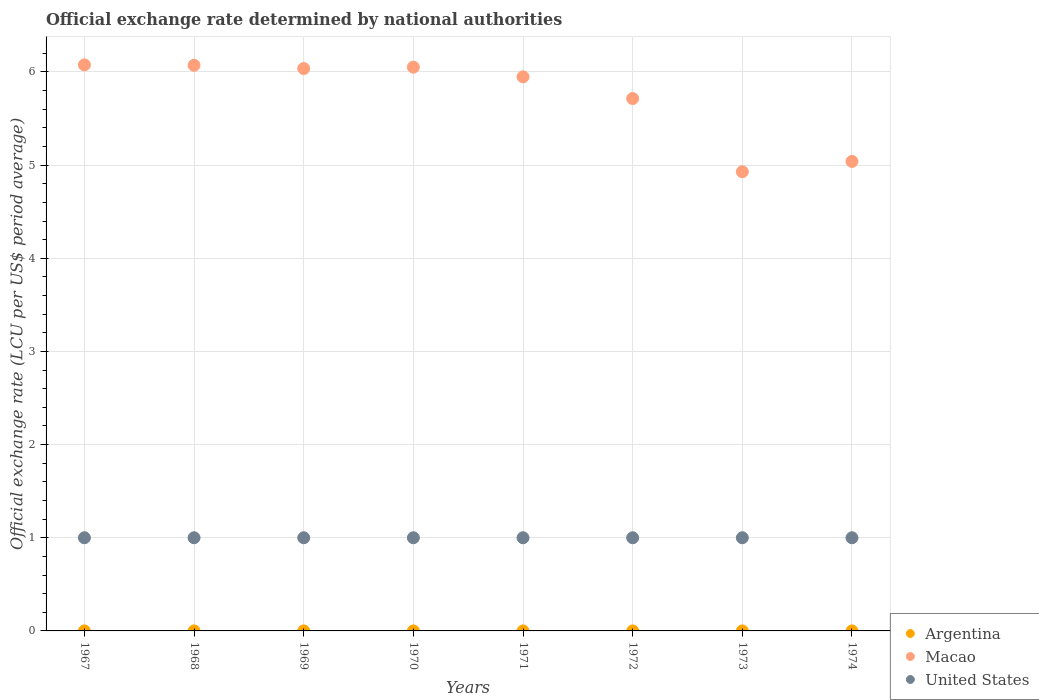How many different coloured dotlines are there?
Provide a short and direct response. 3. What is the official exchange rate in United States in 1970?
Your answer should be compact. 1. Across all years, what is the maximum official exchange rate in Macao?
Offer a terse response. 6.08. Across all years, what is the minimum official exchange rate in Argentina?
Offer a terse response. 3.33424999999917e-11. In which year was the official exchange rate in United States maximum?
Keep it short and to the point. 1967. In which year was the official exchange rate in Argentina minimum?
Provide a short and direct response. 1967. What is the total official exchange rate in United States in the graph?
Keep it short and to the point. 8. What is the difference between the official exchange rate in Argentina in 1967 and that in 1973?
Provide a succinct answer. -1.66574999900083e-11. What is the difference between the official exchange rate in Macao in 1967 and the official exchange rate in Argentina in 1972?
Your response must be concise. 6.08. What is the average official exchange rate in Macao per year?
Provide a short and direct response. 5.73. In the year 1967, what is the difference between the official exchange rate in United States and official exchange rate in Argentina?
Offer a terse response. 1. In how many years, is the official exchange rate in Argentina greater than 3.8 LCU?
Provide a succinct answer. 0. What is the ratio of the official exchange rate in Macao in 1969 to that in 1973?
Make the answer very short. 1.22. Is the difference between the official exchange rate in United States in 1969 and 1972 greater than the difference between the official exchange rate in Argentina in 1969 and 1972?
Provide a succinct answer. Yes. In how many years, is the official exchange rate in United States greater than the average official exchange rate in United States taken over all years?
Your response must be concise. 0. Is the sum of the official exchange rate in Argentina in 1972 and 1973 greater than the maximum official exchange rate in Macao across all years?
Your answer should be compact. No. Is it the case that in every year, the sum of the official exchange rate in Argentina and official exchange rate in United States  is greater than the official exchange rate in Macao?
Provide a succinct answer. No. Is the official exchange rate in Macao strictly less than the official exchange rate in Argentina over the years?
Make the answer very short. No. How many years are there in the graph?
Your answer should be compact. 8. What is the difference between two consecutive major ticks on the Y-axis?
Give a very brief answer. 1. Are the values on the major ticks of Y-axis written in scientific E-notation?
Keep it short and to the point. No. Does the graph contain any zero values?
Offer a terse response. No. Where does the legend appear in the graph?
Your answer should be very brief. Bottom right. How many legend labels are there?
Provide a short and direct response. 3. How are the legend labels stacked?
Provide a succinct answer. Vertical. What is the title of the graph?
Give a very brief answer. Official exchange rate determined by national authorities. What is the label or title of the X-axis?
Provide a short and direct response. Years. What is the label or title of the Y-axis?
Offer a terse response. Official exchange rate (LCU per US$ period average). What is the Official exchange rate (LCU per US$ period average) of Argentina in 1967?
Your answer should be very brief. 3.33424999999917e-11. What is the Official exchange rate (LCU per US$ period average) of Macao in 1967?
Give a very brief answer. 6.08. What is the Official exchange rate (LCU per US$ period average) in Argentina in 1968?
Offer a very short reply. 3.5e-11. What is the Official exchange rate (LCU per US$ period average) of Macao in 1968?
Keep it short and to the point. 6.07. What is the Official exchange rate (LCU per US$ period average) in Argentina in 1969?
Keep it short and to the point. 3.5e-11. What is the Official exchange rate (LCU per US$ period average) of Macao in 1969?
Provide a short and direct response. 6.04. What is the Official exchange rate (LCU per US$ period average) in United States in 1969?
Your response must be concise. 1. What is the Official exchange rate (LCU per US$ period average) in Argentina in 1970?
Your response must be concise. 3.79166666566667e-11. What is the Official exchange rate (LCU per US$ period average) of Macao in 1970?
Make the answer very short. 6.05. What is the Official exchange rate (LCU per US$ period average) in Argentina in 1971?
Offer a terse response. 4.52166666566667e-11. What is the Official exchange rate (LCU per US$ period average) of Macao in 1971?
Provide a short and direct response. 5.95. What is the Official exchange rate (LCU per US$ period average) in Argentina in 1972?
Ensure brevity in your answer.  4.999999999e-11. What is the Official exchange rate (LCU per US$ period average) in Macao in 1972?
Offer a very short reply. 5.71. What is the Official exchange rate (LCU per US$ period average) of United States in 1972?
Your response must be concise. 1. What is the Official exchange rate (LCU per US$ period average) in Argentina in 1973?
Offer a very short reply. 4.999999999e-11. What is the Official exchange rate (LCU per US$ period average) of Macao in 1973?
Provide a short and direct response. 4.93. What is the Official exchange rate (LCU per US$ period average) of Argentina in 1974?
Offer a very short reply. 4.999999999e-11. What is the Official exchange rate (LCU per US$ period average) of Macao in 1974?
Your answer should be very brief. 5.04. What is the Official exchange rate (LCU per US$ period average) of United States in 1974?
Ensure brevity in your answer.  1. Across all years, what is the maximum Official exchange rate (LCU per US$ period average) of Argentina?
Offer a very short reply. 4.999999999e-11. Across all years, what is the maximum Official exchange rate (LCU per US$ period average) of Macao?
Offer a very short reply. 6.08. Across all years, what is the minimum Official exchange rate (LCU per US$ period average) of Argentina?
Your answer should be compact. 3.33424999999917e-11. Across all years, what is the minimum Official exchange rate (LCU per US$ period average) of Macao?
Keep it short and to the point. 4.93. Across all years, what is the minimum Official exchange rate (LCU per US$ period average) of United States?
Make the answer very short. 1. What is the total Official exchange rate (LCU per US$ period average) in Macao in the graph?
Ensure brevity in your answer.  45.87. What is the difference between the Official exchange rate (LCU per US$ period average) in Macao in 1967 and that in 1968?
Give a very brief answer. 0. What is the difference between the Official exchange rate (LCU per US$ period average) of United States in 1967 and that in 1968?
Ensure brevity in your answer.  0. What is the difference between the Official exchange rate (LCU per US$ period average) of Macao in 1967 and that in 1969?
Your answer should be very brief. 0.04. What is the difference between the Official exchange rate (LCU per US$ period average) of United States in 1967 and that in 1969?
Provide a short and direct response. 0. What is the difference between the Official exchange rate (LCU per US$ period average) in Macao in 1967 and that in 1970?
Offer a very short reply. 0.02. What is the difference between the Official exchange rate (LCU per US$ period average) in Argentina in 1967 and that in 1971?
Your answer should be very brief. -0. What is the difference between the Official exchange rate (LCU per US$ period average) in Macao in 1967 and that in 1971?
Provide a succinct answer. 0.13. What is the difference between the Official exchange rate (LCU per US$ period average) of Macao in 1967 and that in 1972?
Your answer should be compact. 0.36. What is the difference between the Official exchange rate (LCU per US$ period average) in Argentina in 1967 and that in 1973?
Your answer should be compact. -0. What is the difference between the Official exchange rate (LCU per US$ period average) of Macao in 1967 and that in 1973?
Ensure brevity in your answer.  1.15. What is the difference between the Official exchange rate (LCU per US$ period average) of United States in 1967 and that in 1973?
Your answer should be compact. 0. What is the difference between the Official exchange rate (LCU per US$ period average) of Argentina in 1967 and that in 1974?
Your answer should be compact. -0. What is the difference between the Official exchange rate (LCU per US$ period average) in Macao in 1967 and that in 1974?
Your answer should be very brief. 1.04. What is the difference between the Official exchange rate (LCU per US$ period average) in United States in 1967 and that in 1974?
Your answer should be very brief. 0. What is the difference between the Official exchange rate (LCU per US$ period average) of Macao in 1968 and that in 1969?
Provide a short and direct response. 0.04. What is the difference between the Official exchange rate (LCU per US$ period average) of United States in 1968 and that in 1969?
Your response must be concise. 0. What is the difference between the Official exchange rate (LCU per US$ period average) in Macao in 1968 and that in 1970?
Your response must be concise. 0.02. What is the difference between the Official exchange rate (LCU per US$ period average) of United States in 1968 and that in 1970?
Give a very brief answer. 0. What is the difference between the Official exchange rate (LCU per US$ period average) in Macao in 1968 and that in 1971?
Give a very brief answer. 0.12. What is the difference between the Official exchange rate (LCU per US$ period average) in United States in 1968 and that in 1971?
Ensure brevity in your answer.  0. What is the difference between the Official exchange rate (LCU per US$ period average) of Argentina in 1968 and that in 1972?
Offer a terse response. -0. What is the difference between the Official exchange rate (LCU per US$ period average) of Macao in 1968 and that in 1972?
Your answer should be very brief. 0.36. What is the difference between the Official exchange rate (LCU per US$ period average) in Macao in 1968 and that in 1973?
Give a very brief answer. 1.14. What is the difference between the Official exchange rate (LCU per US$ period average) of Macao in 1968 and that in 1974?
Your answer should be compact. 1.03. What is the difference between the Official exchange rate (LCU per US$ period average) in Macao in 1969 and that in 1970?
Your answer should be compact. -0.02. What is the difference between the Official exchange rate (LCU per US$ period average) in United States in 1969 and that in 1970?
Offer a very short reply. 0. What is the difference between the Official exchange rate (LCU per US$ period average) in Argentina in 1969 and that in 1971?
Your response must be concise. -0. What is the difference between the Official exchange rate (LCU per US$ period average) of Macao in 1969 and that in 1971?
Provide a succinct answer. 0.09. What is the difference between the Official exchange rate (LCU per US$ period average) in United States in 1969 and that in 1971?
Make the answer very short. 0. What is the difference between the Official exchange rate (LCU per US$ period average) in Macao in 1969 and that in 1972?
Make the answer very short. 0.32. What is the difference between the Official exchange rate (LCU per US$ period average) in Argentina in 1969 and that in 1973?
Your answer should be very brief. -0. What is the difference between the Official exchange rate (LCU per US$ period average) in Macao in 1969 and that in 1973?
Provide a short and direct response. 1.11. What is the difference between the Official exchange rate (LCU per US$ period average) of Argentina in 1969 and that in 1974?
Make the answer very short. -0. What is the difference between the Official exchange rate (LCU per US$ period average) of Macao in 1969 and that in 1974?
Your answer should be very brief. 1. What is the difference between the Official exchange rate (LCU per US$ period average) in United States in 1969 and that in 1974?
Offer a terse response. 0. What is the difference between the Official exchange rate (LCU per US$ period average) in Argentina in 1970 and that in 1971?
Provide a succinct answer. -0. What is the difference between the Official exchange rate (LCU per US$ period average) in Macao in 1970 and that in 1971?
Offer a terse response. 0.1. What is the difference between the Official exchange rate (LCU per US$ period average) of Argentina in 1970 and that in 1972?
Your response must be concise. -0. What is the difference between the Official exchange rate (LCU per US$ period average) in Macao in 1970 and that in 1972?
Make the answer very short. 0.34. What is the difference between the Official exchange rate (LCU per US$ period average) of Argentina in 1970 and that in 1973?
Offer a terse response. -0. What is the difference between the Official exchange rate (LCU per US$ period average) in Macao in 1970 and that in 1973?
Offer a terse response. 1.12. What is the difference between the Official exchange rate (LCU per US$ period average) of Argentina in 1970 and that in 1974?
Ensure brevity in your answer.  -0. What is the difference between the Official exchange rate (LCU per US$ period average) in Macao in 1970 and that in 1974?
Keep it short and to the point. 1.01. What is the difference between the Official exchange rate (LCU per US$ period average) of United States in 1970 and that in 1974?
Your answer should be compact. 0. What is the difference between the Official exchange rate (LCU per US$ period average) in Macao in 1971 and that in 1972?
Offer a very short reply. 0.23. What is the difference between the Official exchange rate (LCU per US$ period average) in Argentina in 1971 and that in 1973?
Offer a terse response. -0. What is the difference between the Official exchange rate (LCU per US$ period average) of Macao in 1971 and that in 1973?
Make the answer very short. 1.02. What is the difference between the Official exchange rate (LCU per US$ period average) of Argentina in 1971 and that in 1974?
Offer a terse response. -0. What is the difference between the Official exchange rate (LCU per US$ period average) in Macao in 1971 and that in 1974?
Provide a succinct answer. 0.91. What is the difference between the Official exchange rate (LCU per US$ period average) in United States in 1971 and that in 1974?
Ensure brevity in your answer.  0. What is the difference between the Official exchange rate (LCU per US$ period average) in Macao in 1972 and that in 1973?
Provide a succinct answer. 0.79. What is the difference between the Official exchange rate (LCU per US$ period average) of Argentina in 1972 and that in 1974?
Ensure brevity in your answer.  0. What is the difference between the Official exchange rate (LCU per US$ period average) in Macao in 1972 and that in 1974?
Make the answer very short. 0.67. What is the difference between the Official exchange rate (LCU per US$ period average) of United States in 1972 and that in 1974?
Your answer should be compact. 0. What is the difference between the Official exchange rate (LCU per US$ period average) of Argentina in 1973 and that in 1974?
Offer a terse response. 0. What is the difference between the Official exchange rate (LCU per US$ period average) of Macao in 1973 and that in 1974?
Your response must be concise. -0.11. What is the difference between the Official exchange rate (LCU per US$ period average) of Argentina in 1967 and the Official exchange rate (LCU per US$ period average) of Macao in 1968?
Your answer should be very brief. -6.07. What is the difference between the Official exchange rate (LCU per US$ period average) of Macao in 1967 and the Official exchange rate (LCU per US$ period average) of United States in 1968?
Your response must be concise. 5.08. What is the difference between the Official exchange rate (LCU per US$ period average) of Argentina in 1967 and the Official exchange rate (LCU per US$ period average) of Macao in 1969?
Your response must be concise. -6.04. What is the difference between the Official exchange rate (LCU per US$ period average) of Macao in 1967 and the Official exchange rate (LCU per US$ period average) of United States in 1969?
Ensure brevity in your answer.  5.08. What is the difference between the Official exchange rate (LCU per US$ period average) of Argentina in 1967 and the Official exchange rate (LCU per US$ period average) of Macao in 1970?
Ensure brevity in your answer.  -6.05. What is the difference between the Official exchange rate (LCU per US$ period average) of Argentina in 1967 and the Official exchange rate (LCU per US$ period average) of United States in 1970?
Offer a very short reply. -1. What is the difference between the Official exchange rate (LCU per US$ period average) in Macao in 1967 and the Official exchange rate (LCU per US$ period average) in United States in 1970?
Your answer should be compact. 5.08. What is the difference between the Official exchange rate (LCU per US$ period average) in Argentina in 1967 and the Official exchange rate (LCU per US$ period average) in Macao in 1971?
Offer a terse response. -5.95. What is the difference between the Official exchange rate (LCU per US$ period average) of Argentina in 1967 and the Official exchange rate (LCU per US$ period average) of United States in 1971?
Provide a short and direct response. -1. What is the difference between the Official exchange rate (LCU per US$ period average) in Macao in 1967 and the Official exchange rate (LCU per US$ period average) in United States in 1971?
Your answer should be very brief. 5.08. What is the difference between the Official exchange rate (LCU per US$ period average) in Argentina in 1967 and the Official exchange rate (LCU per US$ period average) in Macao in 1972?
Make the answer very short. -5.71. What is the difference between the Official exchange rate (LCU per US$ period average) of Macao in 1967 and the Official exchange rate (LCU per US$ period average) of United States in 1972?
Keep it short and to the point. 5.08. What is the difference between the Official exchange rate (LCU per US$ period average) of Argentina in 1967 and the Official exchange rate (LCU per US$ period average) of Macao in 1973?
Offer a very short reply. -4.93. What is the difference between the Official exchange rate (LCU per US$ period average) in Argentina in 1967 and the Official exchange rate (LCU per US$ period average) in United States in 1973?
Your answer should be compact. -1. What is the difference between the Official exchange rate (LCU per US$ period average) in Macao in 1967 and the Official exchange rate (LCU per US$ period average) in United States in 1973?
Offer a very short reply. 5.08. What is the difference between the Official exchange rate (LCU per US$ period average) of Argentina in 1967 and the Official exchange rate (LCU per US$ period average) of Macao in 1974?
Give a very brief answer. -5.04. What is the difference between the Official exchange rate (LCU per US$ period average) of Macao in 1967 and the Official exchange rate (LCU per US$ period average) of United States in 1974?
Make the answer very short. 5.08. What is the difference between the Official exchange rate (LCU per US$ period average) in Argentina in 1968 and the Official exchange rate (LCU per US$ period average) in Macao in 1969?
Your response must be concise. -6.04. What is the difference between the Official exchange rate (LCU per US$ period average) of Argentina in 1968 and the Official exchange rate (LCU per US$ period average) of United States in 1969?
Give a very brief answer. -1. What is the difference between the Official exchange rate (LCU per US$ period average) of Macao in 1968 and the Official exchange rate (LCU per US$ period average) of United States in 1969?
Provide a short and direct response. 5.07. What is the difference between the Official exchange rate (LCU per US$ period average) in Argentina in 1968 and the Official exchange rate (LCU per US$ period average) in Macao in 1970?
Your answer should be compact. -6.05. What is the difference between the Official exchange rate (LCU per US$ period average) of Argentina in 1968 and the Official exchange rate (LCU per US$ period average) of United States in 1970?
Make the answer very short. -1. What is the difference between the Official exchange rate (LCU per US$ period average) of Macao in 1968 and the Official exchange rate (LCU per US$ period average) of United States in 1970?
Keep it short and to the point. 5.07. What is the difference between the Official exchange rate (LCU per US$ period average) of Argentina in 1968 and the Official exchange rate (LCU per US$ period average) of Macao in 1971?
Make the answer very short. -5.95. What is the difference between the Official exchange rate (LCU per US$ period average) in Argentina in 1968 and the Official exchange rate (LCU per US$ period average) in United States in 1971?
Make the answer very short. -1. What is the difference between the Official exchange rate (LCU per US$ period average) in Macao in 1968 and the Official exchange rate (LCU per US$ period average) in United States in 1971?
Your answer should be very brief. 5.07. What is the difference between the Official exchange rate (LCU per US$ period average) of Argentina in 1968 and the Official exchange rate (LCU per US$ period average) of Macao in 1972?
Your response must be concise. -5.71. What is the difference between the Official exchange rate (LCU per US$ period average) of Macao in 1968 and the Official exchange rate (LCU per US$ period average) of United States in 1972?
Give a very brief answer. 5.07. What is the difference between the Official exchange rate (LCU per US$ period average) of Argentina in 1968 and the Official exchange rate (LCU per US$ period average) of Macao in 1973?
Give a very brief answer. -4.93. What is the difference between the Official exchange rate (LCU per US$ period average) of Argentina in 1968 and the Official exchange rate (LCU per US$ period average) of United States in 1973?
Keep it short and to the point. -1. What is the difference between the Official exchange rate (LCU per US$ period average) in Macao in 1968 and the Official exchange rate (LCU per US$ period average) in United States in 1973?
Offer a terse response. 5.07. What is the difference between the Official exchange rate (LCU per US$ period average) in Argentina in 1968 and the Official exchange rate (LCU per US$ period average) in Macao in 1974?
Ensure brevity in your answer.  -5.04. What is the difference between the Official exchange rate (LCU per US$ period average) in Macao in 1968 and the Official exchange rate (LCU per US$ period average) in United States in 1974?
Your answer should be very brief. 5.07. What is the difference between the Official exchange rate (LCU per US$ period average) in Argentina in 1969 and the Official exchange rate (LCU per US$ period average) in Macao in 1970?
Your answer should be very brief. -6.05. What is the difference between the Official exchange rate (LCU per US$ period average) in Macao in 1969 and the Official exchange rate (LCU per US$ period average) in United States in 1970?
Your response must be concise. 5.04. What is the difference between the Official exchange rate (LCU per US$ period average) in Argentina in 1969 and the Official exchange rate (LCU per US$ period average) in Macao in 1971?
Offer a terse response. -5.95. What is the difference between the Official exchange rate (LCU per US$ period average) of Argentina in 1969 and the Official exchange rate (LCU per US$ period average) of United States in 1971?
Your response must be concise. -1. What is the difference between the Official exchange rate (LCU per US$ period average) in Macao in 1969 and the Official exchange rate (LCU per US$ period average) in United States in 1971?
Your answer should be compact. 5.04. What is the difference between the Official exchange rate (LCU per US$ period average) in Argentina in 1969 and the Official exchange rate (LCU per US$ period average) in Macao in 1972?
Your answer should be compact. -5.71. What is the difference between the Official exchange rate (LCU per US$ period average) of Argentina in 1969 and the Official exchange rate (LCU per US$ period average) of United States in 1972?
Provide a short and direct response. -1. What is the difference between the Official exchange rate (LCU per US$ period average) of Macao in 1969 and the Official exchange rate (LCU per US$ period average) of United States in 1972?
Ensure brevity in your answer.  5.04. What is the difference between the Official exchange rate (LCU per US$ period average) of Argentina in 1969 and the Official exchange rate (LCU per US$ period average) of Macao in 1973?
Offer a very short reply. -4.93. What is the difference between the Official exchange rate (LCU per US$ period average) of Argentina in 1969 and the Official exchange rate (LCU per US$ period average) of United States in 1973?
Make the answer very short. -1. What is the difference between the Official exchange rate (LCU per US$ period average) in Macao in 1969 and the Official exchange rate (LCU per US$ period average) in United States in 1973?
Offer a terse response. 5.04. What is the difference between the Official exchange rate (LCU per US$ period average) of Argentina in 1969 and the Official exchange rate (LCU per US$ period average) of Macao in 1974?
Make the answer very short. -5.04. What is the difference between the Official exchange rate (LCU per US$ period average) in Argentina in 1969 and the Official exchange rate (LCU per US$ period average) in United States in 1974?
Provide a short and direct response. -1. What is the difference between the Official exchange rate (LCU per US$ period average) of Macao in 1969 and the Official exchange rate (LCU per US$ period average) of United States in 1974?
Your answer should be compact. 5.04. What is the difference between the Official exchange rate (LCU per US$ period average) of Argentina in 1970 and the Official exchange rate (LCU per US$ period average) of Macao in 1971?
Your response must be concise. -5.95. What is the difference between the Official exchange rate (LCU per US$ period average) in Macao in 1970 and the Official exchange rate (LCU per US$ period average) in United States in 1971?
Make the answer very short. 5.05. What is the difference between the Official exchange rate (LCU per US$ period average) in Argentina in 1970 and the Official exchange rate (LCU per US$ period average) in Macao in 1972?
Your response must be concise. -5.71. What is the difference between the Official exchange rate (LCU per US$ period average) of Macao in 1970 and the Official exchange rate (LCU per US$ period average) of United States in 1972?
Your answer should be very brief. 5.05. What is the difference between the Official exchange rate (LCU per US$ period average) of Argentina in 1970 and the Official exchange rate (LCU per US$ period average) of Macao in 1973?
Your answer should be very brief. -4.93. What is the difference between the Official exchange rate (LCU per US$ period average) of Argentina in 1970 and the Official exchange rate (LCU per US$ period average) of United States in 1973?
Offer a terse response. -1. What is the difference between the Official exchange rate (LCU per US$ period average) in Macao in 1970 and the Official exchange rate (LCU per US$ period average) in United States in 1973?
Make the answer very short. 5.05. What is the difference between the Official exchange rate (LCU per US$ period average) of Argentina in 1970 and the Official exchange rate (LCU per US$ period average) of Macao in 1974?
Provide a short and direct response. -5.04. What is the difference between the Official exchange rate (LCU per US$ period average) in Macao in 1970 and the Official exchange rate (LCU per US$ period average) in United States in 1974?
Your answer should be compact. 5.05. What is the difference between the Official exchange rate (LCU per US$ period average) in Argentina in 1971 and the Official exchange rate (LCU per US$ period average) in Macao in 1972?
Give a very brief answer. -5.71. What is the difference between the Official exchange rate (LCU per US$ period average) of Argentina in 1971 and the Official exchange rate (LCU per US$ period average) of United States in 1972?
Give a very brief answer. -1. What is the difference between the Official exchange rate (LCU per US$ period average) in Macao in 1971 and the Official exchange rate (LCU per US$ period average) in United States in 1972?
Give a very brief answer. 4.95. What is the difference between the Official exchange rate (LCU per US$ period average) in Argentina in 1971 and the Official exchange rate (LCU per US$ period average) in Macao in 1973?
Keep it short and to the point. -4.93. What is the difference between the Official exchange rate (LCU per US$ period average) of Argentina in 1971 and the Official exchange rate (LCU per US$ period average) of United States in 1973?
Offer a terse response. -1. What is the difference between the Official exchange rate (LCU per US$ period average) in Macao in 1971 and the Official exchange rate (LCU per US$ period average) in United States in 1973?
Offer a very short reply. 4.95. What is the difference between the Official exchange rate (LCU per US$ period average) in Argentina in 1971 and the Official exchange rate (LCU per US$ period average) in Macao in 1974?
Make the answer very short. -5.04. What is the difference between the Official exchange rate (LCU per US$ period average) in Argentina in 1971 and the Official exchange rate (LCU per US$ period average) in United States in 1974?
Offer a very short reply. -1. What is the difference between the Official exchange rate (LCU per US$ period average) in Macao in 1971 and the Official exchange rate (LCU per US$ period average) in United States in 1974?
Your response must be concise. 4.95. What is the difference between the Official exchange rate (LCU per US$ period average) of Argentina in 1972 and the Official exchange rate (LCU per US$ period average) of Macao in 1973?
Your answer should be compact. -4.93. What is the difference between the Official exchange rate (LCU per US$ period average) in Macao in 1972 and the Official exchange rate (LCU per US$ period average) in United States in 1973?
Ensure brevity in your answer.  4.71. What is the difference between the Official exchange rate (LCU per US$ period average) in Argentina in 1972 and the Official exchange rate (LCU per US$ period average) in Macao in 1974?
Keep it short and to the point. -5.04. What is the difference between the Official exchange rate (LCU per US$ period average) in Argentina in 1972 and the Official exchange rate (LCU per US$ period average) in United States in 1974?
Make the answer very short. -1. What is the difference between the Official exchange rate (LCU per US$ period average) of Macao in 1972 and the Official exchange rate (LCU per US$ period average) of United States in 1974?
Your response must be concise. 4.71. What is the difference between the Official exchange rate (LCU per US$ period average) of Argentina in 1973 and the Official exchange rate (LCU per US$ period average) of Macao in 1974?
Make the answer very short. -5.04. What is the difference between the Official exchange rate (LCU per US$ period average) of Argentina in 1973 and the Official exchange rate (LCU per US$ period average) of United States in 1974?
Offer a terse response. -1. What is the difference between the Official exchange rate (LCU per US$ period average) of Macao in 1973 and the Official exchange rate (LCU per US$ period average) of United States in 1974?
Your answer should be compact. 3.93. What is the average Official exchange rate (LCU per US$ period average) in Macao per year?
Provide a short and direct response. 5.73. What is the average Official exchange rate (LCU per US$ period average) of United States per year?
Offer a terse response. 1. In the year 1967, what is the difference between the Official exchange rate (LCU per US$ period average) of Argentina and Official exchange rate (LCU per US$ period average) of Macao?
Ensure brevity in your answer.  -6.08. In the year 1967, what is the difference between the Official exchange rate (LCU per US$ period average) in Macao and Official exchange rate (LCU per US$ period average) in United States?
Ensure brevity in your answer.  5.08. In the year 1968, what is the difference between the Official exchange rate (LCU per US$ period average) in Argentina and Official exchange rate (LCU per US$ period average) in Macao?
Provide a succinct answer. -6.07. In the year 1968, what is the difference between the Official exchange rate (LCU per US$ period average) of Macao and Official exchange rate (LCU per US$ period average) of United States?
Provide a short and direct response. 5.07. In the year 1969, what is the difference between the Official exchange rate (LCU per US$ period average) of Argentina and Official exchange rate (LCU per US$ period average) of Macao?
Offer a very short reply. -6.04. In the year 1969, what is the difference between the Official exchange rate (LCU per US$ period average) of Argentina and Official exchange rate (LCU per US$ period average) of United States?
Your answer should be compact. -1. In the year 1969, what is the difference between the Official exchange rate (LCU per US$ period average) in Macao and Official exchange rate (LCU per US$ period average) in United States?
Make the answer very short. 5.04. In the year 1970, what is the difference between the Official exchange rate (LCU per US$ period average) of Argentina and Official exchange rate (LCU per US$ period average) of Macao?
Give a very brief answer. -6.05. In the year 1970, what is the difference between the Official exchange rate (LCU per US$ period average) of Macao and Official exchange rate (LCU per US$ period average) of United States?
Ensure brevity in your answer.  5.05. In the year 1971, what is the difference between the Official exchange rate (LCU per US$ period average) in Argentina and Official exchange rate (LCU per US$ period average) in Macao?
Your answer should be very brief. -5.95. In the year 1971, what is the difference between the Official exchange rate (LCU per US$ period average) in Argentina and Official exchange rate (LCU per US$ period average) in United States?
Offer a very short reply. -1. In the year 1971, what is the difference between the Official exchange rate (LCU per US$ period average) in Macao and Official exchange rate (LCU per US$ period average) in United States?
Ensure brevity in your answer.  4.95. In the year 1972, what is the difference between the Official exchange rate (LCU per US$ period average) in Argentina and Official exchange rate (LCU per US$ period average) in Macao?
Make the answer very short. -5.71. In the year 1972, what is the difference between the Official exchange rate (LCU per US$ period average) in Argentina and Official exchange rate (LCU per US$ period average) in United States?
Make the answer very short. -1. In the year 1972, what is the difference between the Official exchange rate (LCU per US$ period average) of Macao and Official exchange rate (LCU per US$ period average) of United States?
Offer a very short reply. 4.71. In the year 1973, what is the difference between the Official exchange rate (LCU per US$ period average) of Argentina and Official exchange rate (LCU per US$ period average) of Macao?
Your response must be concise. -4.93. In the year 1973, what is the difference between the Official exchange rate (LCU per US$ period average) in Macao and Official exchange rate (LCU per US$ period average) in United States?
Give a very brief answer. 3.93. In the year 1974, what is the difference between the Official exchange rate (LCU per US$ period average) in Argentina and Official exchange rate (LCU per US$ period average) in Macao?
Offer a very short reply. -5.04. In the year 1974, what is the difference between the Official exchange rate (LCU per US$ period average) in Macao and Official exchange rate (LCU per US$ period average) in United States?
Give a very brief answer. 4.04. What is the ratio of the Official exchange rate (LCU per US$ period average) of Argentina in 1967 to that in 1968?
Your answer should be very brief. 0.95. What is the ratio of the Official exchange rate (LCU per US$ period average) in Argentina in 1967 to that in 1969?
Your answer should be compact. 0.95. What is the ratio of the Official exchange rate (LCU per US$ period average) of Macao in 1967 to that in 1969?
Offer a very short reply. 1.01. What is the ratio of the Official exchange rate (LCU per US$ period average) in Argentina in 1967 to that in 1970?
Ensure brevity in your answer.  0.88. What is the ratio of the Official exchange rate (LCU per US$ period average) of United States in 1967 to that in 1970?
Your answer should be compact. 1. What is the ratio of the Official exchange rate (LCU per US$ period average) in Argentina in 1967 to that in 1971?
Provide a succinct answer. 0.74. What is the ratio of the Official exchange rate (LCU per US$ period average) of Macao in 1967 to that in 1971?
Your answer should be compact. 1.02. What is the ratio of the Official exchange rate (LCU per US$ period average) in United States in 1967 to that in 1971?
Offer a very short reply. 1. What is the ratio of the Official exchange rate (LCU per US$ period average) in Argentina in 1967 to that in 1972?
Make the answer very short. 0.67. What is the ratio of the Official exchange rate (LCU per US$ period average) of Macao in 1967 to that in 1972?
Offer a very short reply. 1.06. What is the ratio of the Official exchange rate (LCU per US$ period average) of Argentina in 1967 to that in 1973?
Provide a succinct answer. 0.67. What is the ratio of the Official exchange rate (LCU per US$ period average) of Macao in 1967 to that in 1973?
Make the answer very short. 1.23. What is the ratio of the Official exchange rate (LCU per US$ period average) of Argentina in 1967 to that in 1974?
Make the answer very short. 0.67. What is the ratio of the Official exchange rate (LCU per US$ period average) of Macao in 1967 to that in 1974?
Keep it short and to the point. 1.21. What is the ratio of the Official exchange rate (LCU per US$ period average) of Macao in 1968 to that in 1969?
Ensure brevity in your answer.  1.01. What is the ratio of the Official exchange rate (LCU per US$ period average) of United States in 1968 to that in 1969?
Give a very brief answer. 1. What is the ratio of the Official exchange rate (LCU per US$ period average) in Macao in 1968 to that in 1970?
Provide a succinct answer. 1. What is the ratio of the Official exchange rate (LCU per US$ period average) of United States in 1968 to that in 1970?
Ensure brevity in your answer.  1. What is the ratio of the Official exchange rate (LCU per US$ period average) in Argentina in 1968 to that in 1971?
Provide a short and direct response. 0.77. What is the ratio of the Official exchange rate (LCU per US$ period average) in Macao in 1968 to that in 1971?
Provide a short and direct response. 1.02. What is the ratio of the Official exchange rate (LCU per US$ period average) in Macao in 1968 to that in 1973?
Give a very brief answer. 1.23. What is the ratio of the Official exchange rate (LCU per US$ period average) in Argentina in 1968 to that in 1974?
Ensure brevity in your answer.  0.7. What is the ratio of the Official exchange rate (LCU per US$ period average) in Macao in 1968 to that in 1974?
Offer a very short reply. 1.2. What is the ratio of the Official exchange rate (LCU per US$ period average) in United States in 1968 to that in 1974?
Ensure brevity in your answer.  1. What is the ratio of the Official exchange rate (LCU per US$ period average) in Macao in 1969 to that in 1970?
Ensure brevity in your answer.  1. What is the ratio of the Official exchange rate (LCU per US$ period average) in Argentina in 1969 to that in 1971?
Keep it short and to the point. 0.77. What is the ratio of the Official exchange rate (LCU per US$ period average) of Macao in 1969 to that in 1971?
Provide a short and direct response. 1.01. What is the ratio of the Official exchange rate (LCU per US$ period average) of United States in 1969 to that in 1971?
Your answer should be very brief. 1. What is the ratio of the Official exchange rate (LCU per US$ period average) in Macao in 1969 to that in 1972?
Ensure brevity in your answer.  1.06. What is the ratio of the Official exchange rate (LCU per US$ period average) in United States in 1969 to that in 1972?
Provide a short and direct response. 1. What is the ratio of the Official exchange rate (LCU per US$ period average) of Macao in 1969 to that in 1973?
Keep it short and to the point. 1.22. What is the ratio of the Official exchange rate (LCU per US$ period average) of United States in 1969 to that in 1973?
Your answer should be compact. 1. What is the ratio of the Official exchange rate (LCU per US$ period average) in Macao in 1969 to that in 1974?
Your answer should be very brief. 1.2. What is the ratio of the Official exchange rate (LCU per US$ period average) of Argentina in 1970 to that in 1971?
Provide a short and direct response. 0.84. What is the ratio of the Official exchange rate (LCU per US$ period average) of Macao in 1970 to that in 1971?
Give a very brief answer. 1.02. What is the ratio of the Official exchange rate (LCU per US$ period average) in Argentina in 1970 to that in 1972?
Offer a very short reply. 0.76. What is the ratio of the Official exchange rate (LCU per US$ period average) of Macao in 1970 to that in 1972?
Make the answer very short. 1.06. What is the ratio of the Official exchange rate (LCU per US$ period average) in United States in 1970 to that in 1972?
Make the answer very short. 1. What is the ratio of the Official exchange rate (LCU per US$ period average) in Argentina in 1970 to that in 1973?
Give a very brief answer. 0.76. What is the ratio of the Official exchange rate (LCU per US$ period average) of Macao in 1970 to that in 1973?
Provide a succinct answer. 1.23. What is the ratio of the Official exchange rate (LCU per US$ period average) in Argentina in 1970 to that in 1974?
Your answer should be very brief. 0.76. What is the ratio of the Official exchange rate (LCU per US$ period average) of Macao in 1970 to that in 1974?
Give a very brief answer. 1.2. What is the ratio of the Official exchange rate (LCU per US$ period average) of Argentina in 1971 to that in 1972?
Keep it short and to the point. 0.9. What is the ratio of the Official exchange rate (LCU per US$ period average) of Macao in 1971 to that in 1972?
Make the answer very short. 1.04. What is the ratio of the Official exchange rate (LCU per US$ period average) of United States in 1971 to that in 1972?
Offer a very short reply. 1. What is the ratio of the Official exchange rate (LCU per US$ period average) in Argentina in 1971 to that in 1973?
Keep it short and to the point. 0.9. What is the ratio of the Official exchange rate (LCU per US$ period average) of Macao in 1971 to that in 1973?
Keep it short and to the point. 1.21. What is the ratio of the Official exchange rate (LCU per US$ period average) in Argentina in 1971 to that in 1974?
Your response must be concise. 0.9. What is the ratio of the Official exchange rate (LCU per US$ period average) of Macao in 1971 to that in 1974?
Your answer should be very brief. 1.18. What is the ratio of the Official exchange rate (LCU per US$ period average) in Argentina in 1972 to that in 1973?
Provide a short and direct response. 1. What is the ratio of the Official exchange rate (LCU per US$ period average) in Macao in 1972 to that in 1973?
Give a very brief answer. 1.16. What is the ratio of the Official exchange rate (LCU per US$ period average) of Argentina in 1972 to that in 1974?
Offer a very short reply. 1. What is the ratio of the Official exchange rate (LCU per US$ period average) in Macao in 1972 to that in 1974?
Offer a terse response. 1.13. What is the ratio of the Official exchange rate (LCU per US$ period average) of United States in 1972 to that in 1974?
Keep it short and to the point. 1. What is the ratio of the Official exchange rate (LCU per US$ period average) in Argentina in 1973 to that in 1974?
Your answer should be compact. 1. What is the ratio of the Official exchange rate (LCU per US$ period average) in Macao in 1973 to that in 1974?
Give a very brief answer. 0.98. What is the ratio of the Official exchange rate (LCU per US$ period average) of United States in 1973 to that in 1974?
Give a very brief answer. 1. What is the difference between the highest and the second highest Official exchange rate (LCU per US$ period average) of Macao?
Offer a very short reply. 0. What is the difference between the highest and the lowest Official exchange rate (LCU per US$ period average) in Macao?
Your answer should be compact. 1.15. 